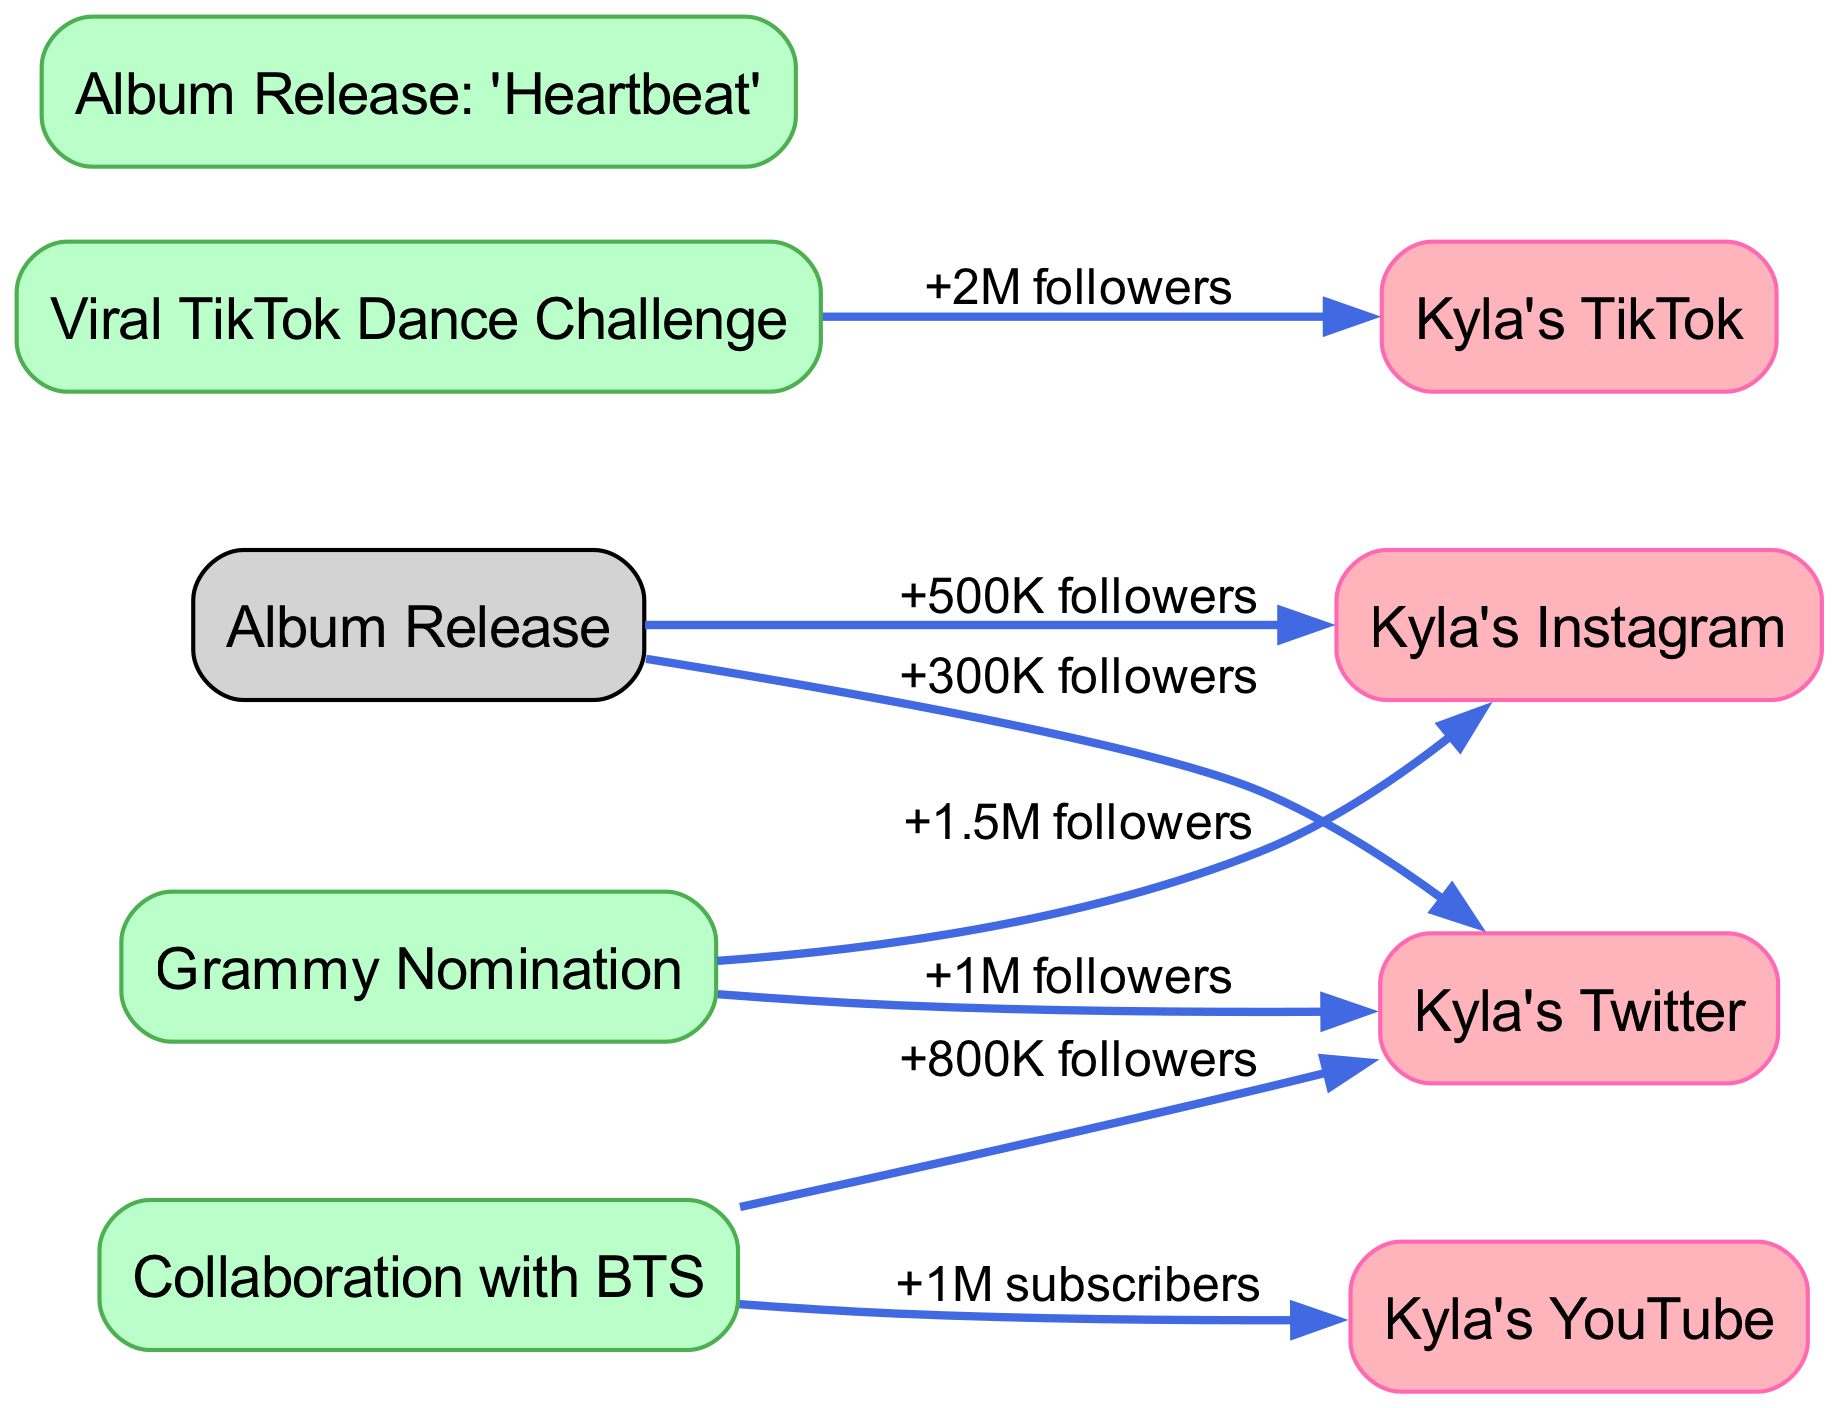What is the total number of nodes in the diagram? To find the total number of nodes, we count all distinct entries listed in the nodes section of the graph. There are 8 nodes: 4 social media platforms and 4 events.
Answer: 8 Which event contributed the most followers to Kyla's TikTok? The edge from "Viral TikTok Dance Challenge" to "Kyla's TikTok" shows "+2M followers," indicating that this event resulted in the highest follower increase for this platform.
Answer: Viral TikTok Dance Challenge How many followers did Kyla gain on Twitter after her Grammy Nomination? The edge from "Grammy Nomination" to "Kyla's Twitter" indicates a gain of "+1M followers." There is also an edge from "Collaboration with BTS" to "Kyla's Twitter" indicating "+800K followers." Summing these gives 1M + 800K = 1.8M followers total from both events, but only from Grammy Nomination it is 1M.
Answer: 1M followers Which platform saw the second highest follower growth from an event? "Kyla's Instagram" gained +1.5M followers from the "Grammy Nomination," which is the second highest after Kyla's TikTok from the "Viral TikTok Dance Challenge," which gained +2M followers.
Answer: Kyla's Instagram What is the relationship between "Collaboration with BTS" and "Kyla's YouTube"? The edge indicates that "Collaboration with BTS" leads to "Kyla's YouTube" with a label of "+1M subscribers," establishing that the collaboration increased her subscribers on that platform.
Answer: +1M subscribers 